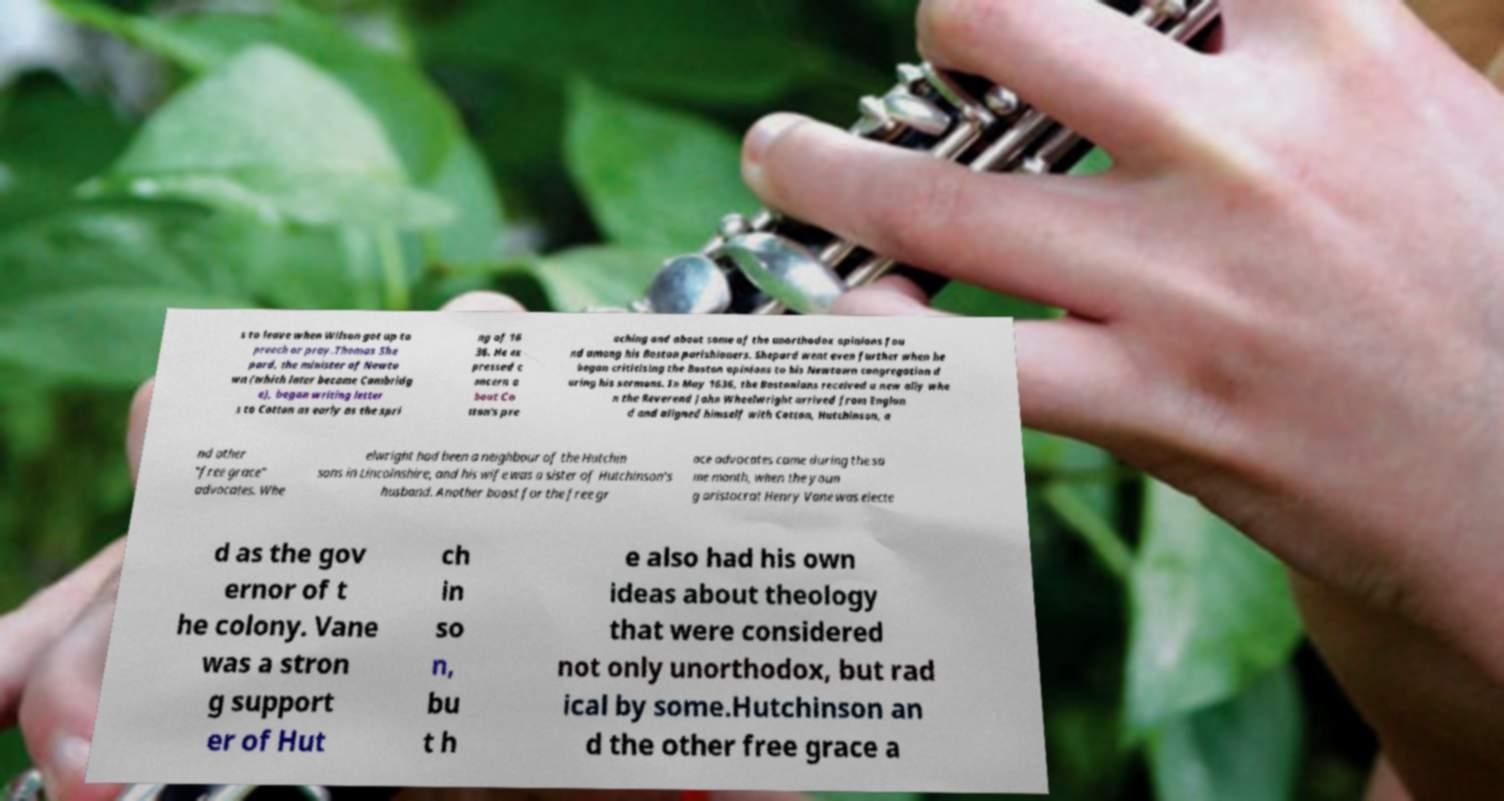There's text embedded in this image that I need extracted. Can you transcribe it verbatim? s to leave when Wilson got up to preach or pray.Thomas She pard, the minister of Newto wn (which later became Cambridg e), began writing letter s to Cotton as early as the spri ng of 16 36. He ex pressed c oncern a bout Co tton's pre aching and about some of the unorthodox opinions fou nd among his Boston parishioners. Shepard went even further when he began criticising the Boston opinions to his Newtown congregation d uring his sermons. In May 1636, the Bostonians received a new ally whe n the Reverend John Wheelwright arrived from Englan d and aligned himself with Cotton, Hutchinson, a nd other "free grace" advocates. Whe elwright had been a neighbour of the Hutchin sons in Lincolnshire, and his wife was a sister of Hutchinson's husband. Another boost for the free gr ace advocates came during the sa me month, when the youn g aristocrat Henry Vane was electe d as the gov ernor of t he colony. Vane was a stron g support er of Hut ch in so n, bu t h e also had his own ideas about theology that were considered not only unorthodox, but rad ical by some.Hutchinson an d the other free grace a 